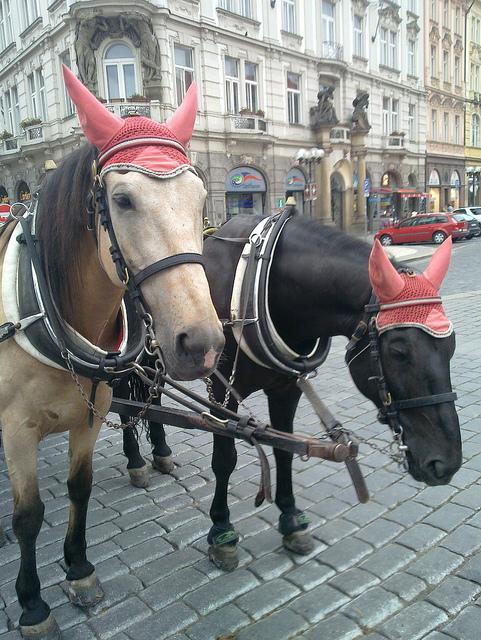What color is the sidewalk?
Give a very brief answer. Gray. Do the horses have red ears?
Give a very brief answer. Yes. How many horses are visible?
Be succinct. 2. 